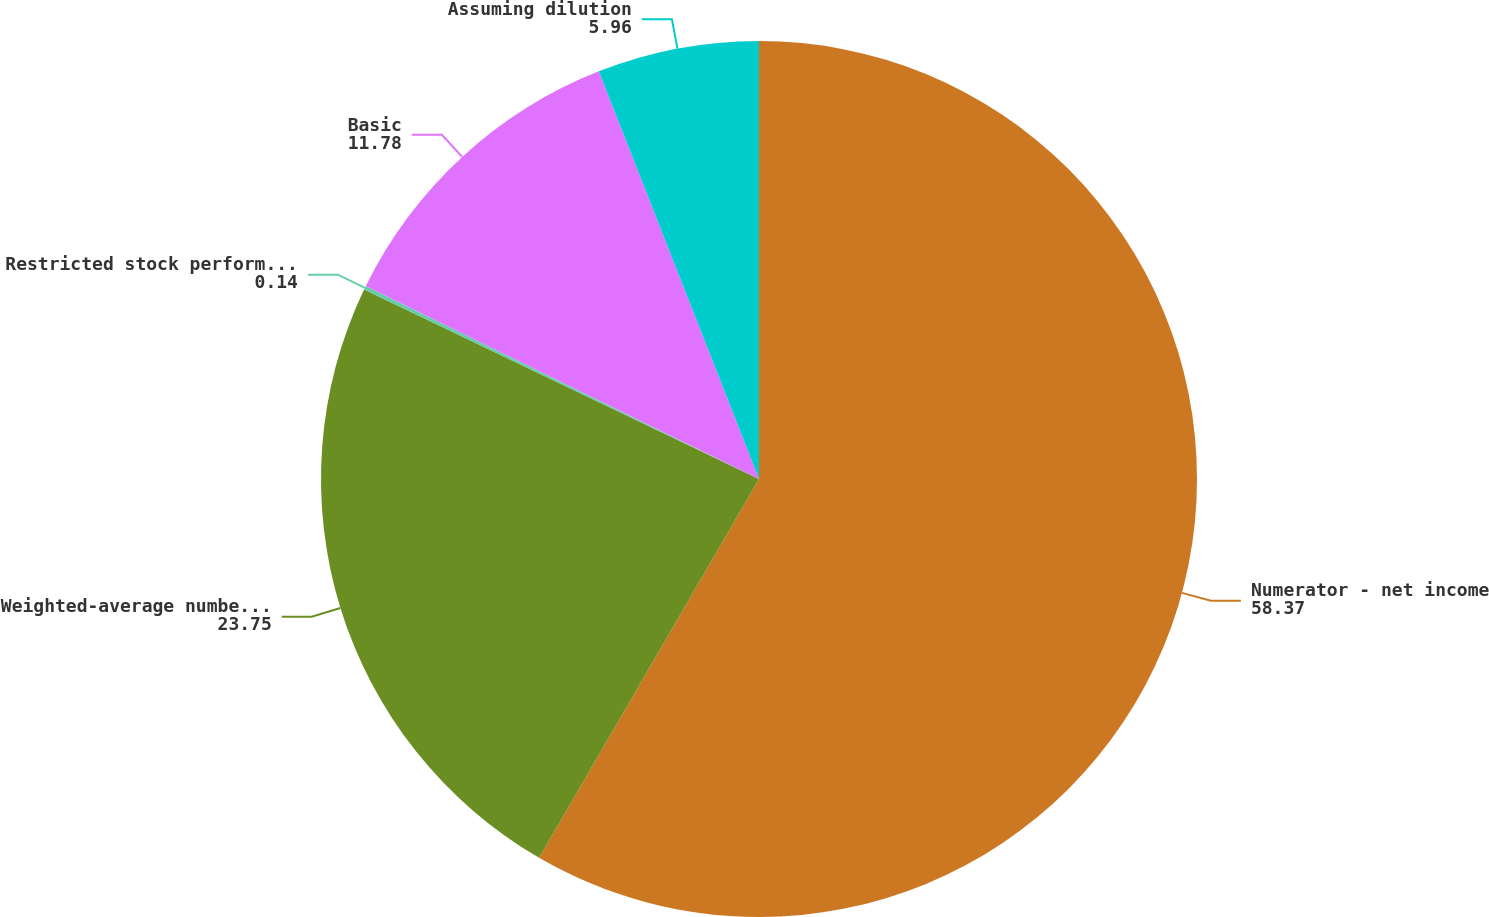Convert chart. <chart><loc_0><loc_0><loc_500><loc_500><pie_chart><fcel>Numerator - net income<fcel>Weighted-average number of<fcel>Restricted stock performance<fcel>Basic<fcel>Assuming dilution<nl><fcel>58.37%<fcel>23.75%<fcel>0.14%<fcel>11.78%<fcel>5.96%<nl></chart> 